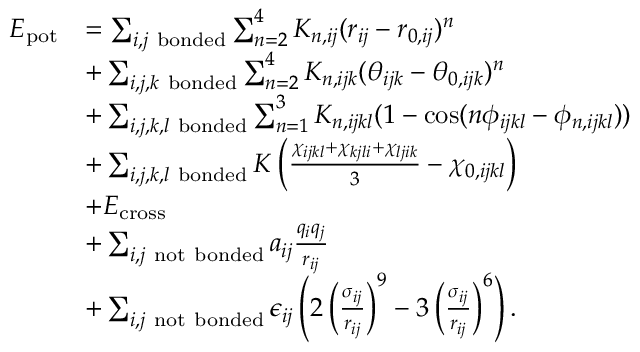<formula> <loc_0><loc_0><loc_500><loc_500>\begin{array} { r l } { E _ { p o t } } & { = \sum _ { i , j b o n d e d } \sum _ { n = 2 } ^ { 4 } K _ { n , i j } ( r _ { i j } - r _ { 0 , i j } ) ^ { n } } \\ & { + \sum _ { i , j , k b o n d e d } \sum _ { n = 2 } ^ { 4 } K _ { n , i j k } ( \theta _ { i j k } - \theta _ { 0 , i j k } ) ^ { n } } \\ & { + \sum _ { i , j , k , l b o n d e d } \sum _ { n = 1 } ^ { 3 } K _ { n , i j k l } ( 1 - \cos ( n \phi _ { i j k l } - \phi _ { n , i j k l } ) ) } \\ & { + \sum _ { i , j , k , l b o n d e d } K \left ( \frac { \chi _ { i j k l } + \chi _ { k j l i } + \chi _ { l j i k } } { 3 } - \chi _ { 0 , i j k l } \right ) } \\ & { + E _ { c r o s s } } \\ & { + \sum _ { i , j n o t b o n d e d } a _ { i j } \frac { q _ { i } q _ { j } } { r _ { i j } } } \\ & { + \sum _ { i , j n o t b o n d e d } \epsilon _ { i j } \left ( 2 \left ( \frac { \sigma _ { i j } } { r _ { i j } } \right ) ^ { 9 } - 3 \left ( \frac { \sigma _ { i j } } { r _ { i j } } \right ) ^ { 6 } \right ) . } \end{array}</formula> 